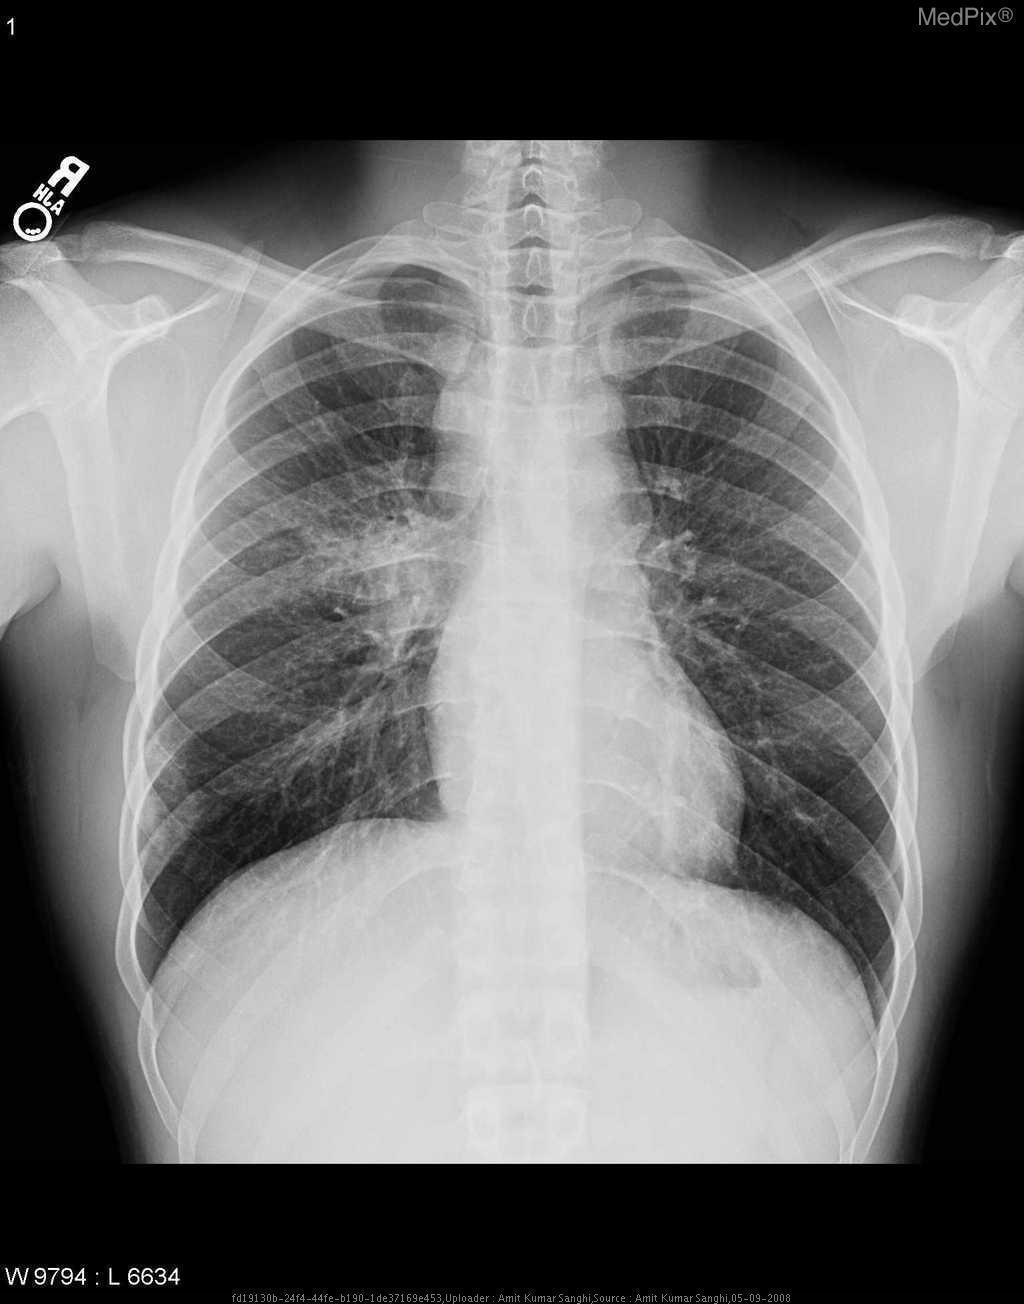Is the cardiac contour normal in shape?
Answer briefly. Yes. Are the costophrenic angles sharp?
Write a very short answer. Yes. Is there no evidence of blunting of the costophrenic angles?
Give a very brief answer. Yes. Are the hilar soft tissue densities symmetric?
Answer briefly. No. Are the soft tissue densities in the left hilum equivalent in size to the soft tissue densities in the right hilum?
Give a very brief answer. No. Are there any fractures in any of the ribs?
Short answer required. No. Are any of the patient's ribs fractured?
Give a very brief answer. No. 